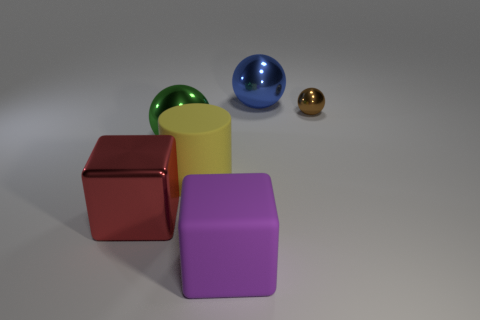Subtract all big spheres. How many spheres are left? 1 Subtract all blue spheres. How many spheres are left? 2 Add 2 purple objects. How many purple objects exist? 3 Add 3 small brown shiny cubes. How many objects exist? 9 Subtract 0 cyan balls. How many objects are left? 6 Subtract all cylinders. How many objects are left? 5 Subtract all green blocks. Subtract all red balls. How many blocks are left? 2 Subtract all red blocks. How many green spheres are left? 1 Subtract all big blue matte cubes. Subtract all blue spheres. How many objects are left? 5 Add 5 red shiny objects. How many red shiny objects are left? 6 